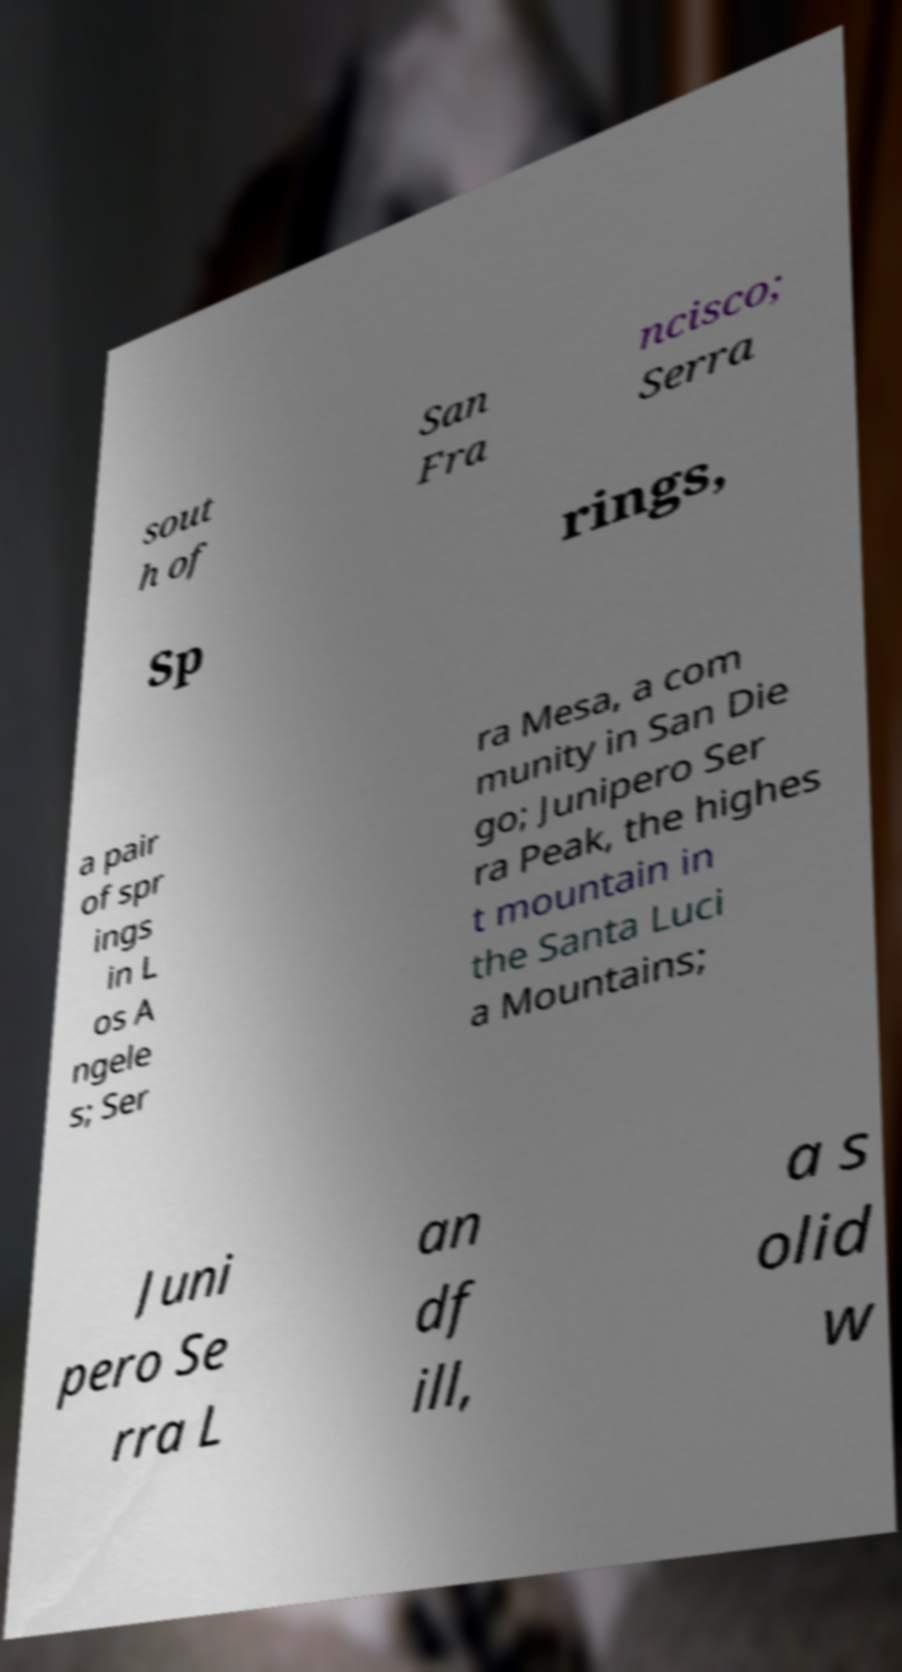Could you extract and type out the text from this image? sout h of San Fra ncisco; Serra Sp rings, a pair of spr ings in L os A ngele s; Ser ra Mesa, a com munity in San Die go; Junipero Ser ra Peak, the highes t mountain in the Santa Luci a Mountains; Juni pero Se rra L an df ill, a s olid w 